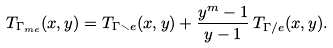<formula> <loc_0><loc_0><loc_500><loc_500>T _ { \Gamma _ { m e } } ( x , y ) = T _ { \Gamma \smallsetminus e } ( x , y ) + \frac { y ^ { m } - 1 } { y - 1 } \, T _ { \Gamma / e } ( x , y ) .</formula> 